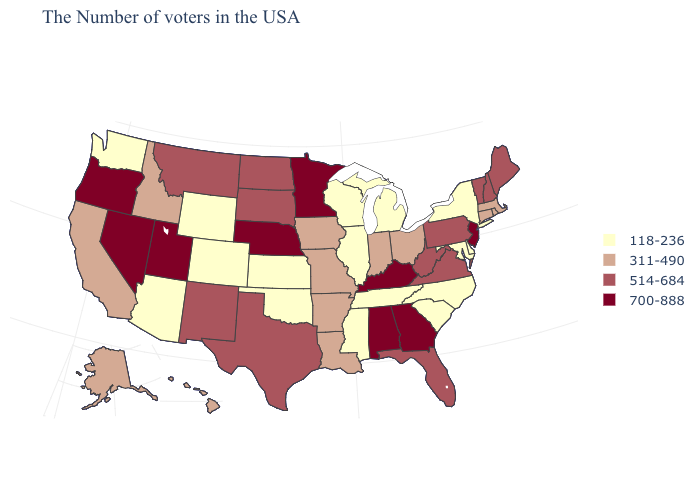What is the value of New York?
Quick response, please. 118-236. Name the states that have a value in the range 700-888?
Short answer required. New Jersey, Georgia, Kentucky, Alabama, Minnesota, Nebraska, Utah, Nevada, Oregon. Does Missouri have a lower value than South Dakota?
Keep it brief. Yes. Among the states that border Washington , which have the lowest value?
Keep it brief. Idaho. What is the value of Arizona?
Keep it brief. 118-236. Does the map have missing data?
Concise answer only. No. Does Alaska have a higher value than New Jersey?
Keep it brief. No. What is the lowest value in the USA?
Answer briefly. 118-236. What is the value of Oklahoma?
Give a very brief answer. 118-236. Does Oregon have the lowest value in the West?
Answer briefly. No. Among the states that border Massachusetts , does Rhode Island have the lowest value?
Answer briefly. No. How many symbols are there in the legend?
Short answer required. 4. Name the states that have a value in the range 311-490?
Keep it brief. Massachusetts, Rhode Island, Connecticut, Ohio, Indiana, Louisiana, Missouri, Arkansas, Iowa, Idaho, California, Alaska, Hawaii. What is the value of New Mexico?
Quick response, please. 514-684. Which states hav the highest value in the MidWest?
Give a very brief answer. Minnesota, Nebraska. 